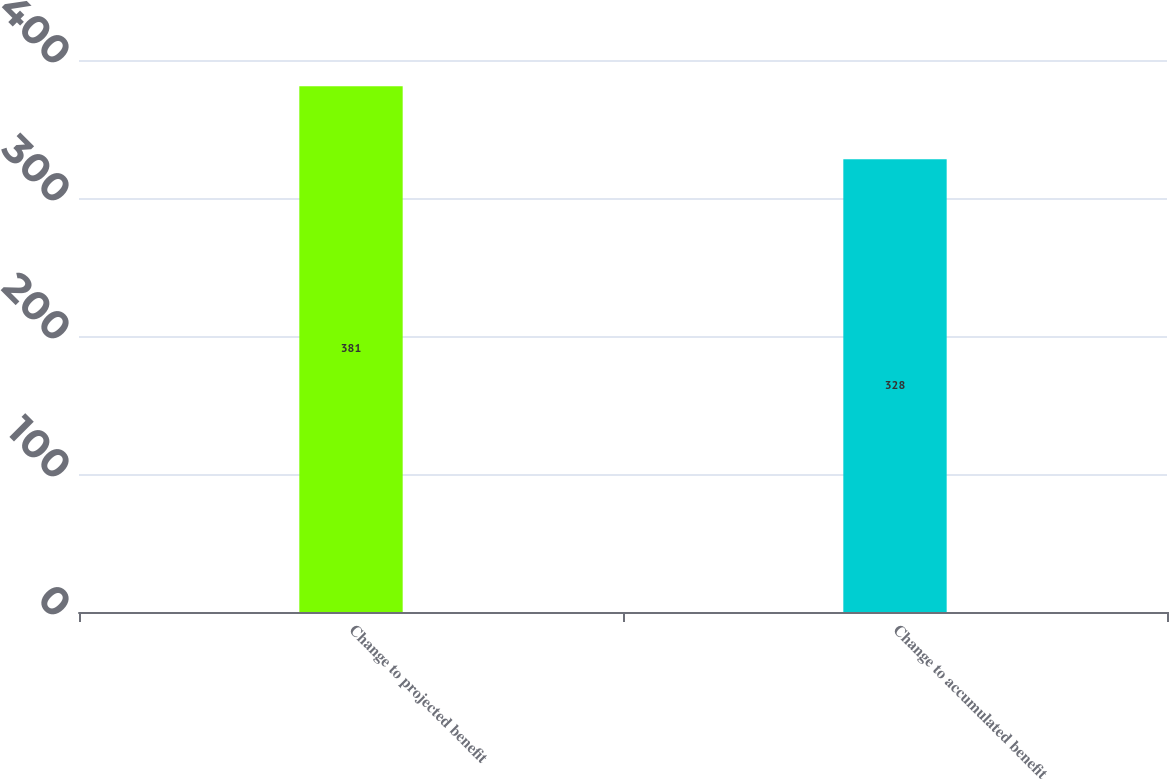Convert chart to OTSL. <chart><loc_0><loc_0><loc_500><loc_500><bar_chart><fcel>Change to projected benefit<fcel>Change to accumulated benefit<nl><fcel>381<fcel>328<nl></chart> 